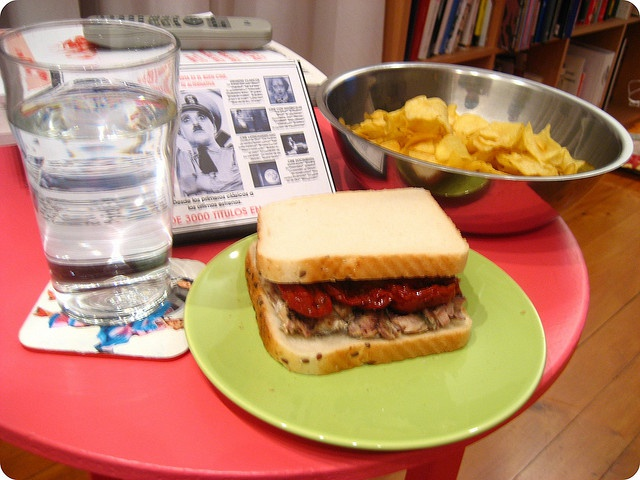Describe the objects in this image and their specific colors. I can see cup in white, lightgray, darkgray, and gray tones, dining table in white, salmon, brown, and red tones, bowl in white, maroon, brown, orange, and black tones, sandwich in white, tan, beige, red, and maroon tones, and remote in white, darkgray, and gray tones in this image. 